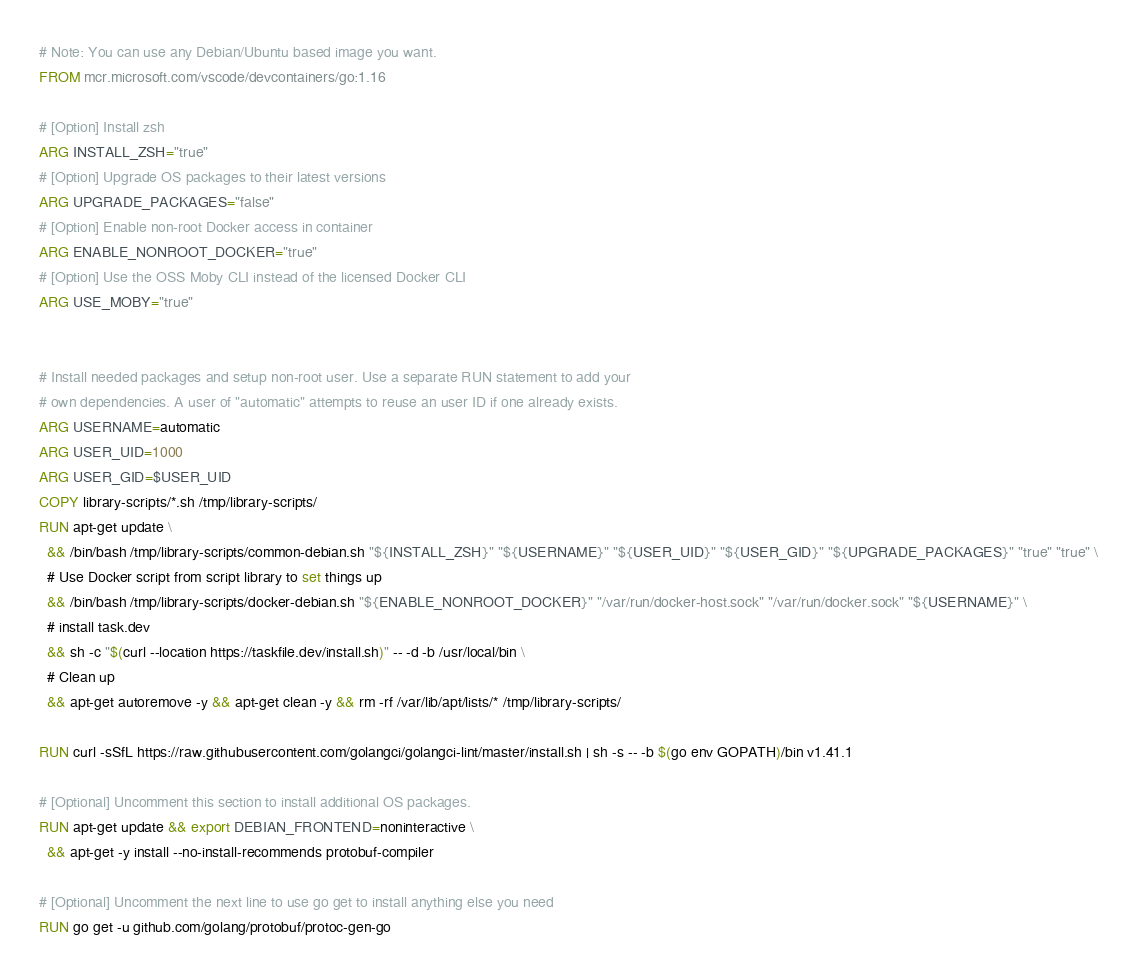Convert code to text. <code><loc_0><loc_0><loc_500><loc_500><_Dockerfile_># Note: You can use any Debian/Ubuntu based image you want. 
FROM mcr.microsoft.com/vscode/devcontainers/go:1.16

# [Option] Install zsh
ARG INSTALL_ZSH="true"
# [Option] Upgrade OS packages to their latest versions
ARG UPGRADE_PACKAGES="false"
# [Option] Enable non-root Docker access in container
ARG ENABLE_NONROOT_DOCKER="true"
# [Option] Use the OSS Moby CLI instead of the licensed Docker CLI
ARG USE_MOBY="true"


# Install needed packages and setup non-root user. Use a separate RUN statement to add your
# own dependencies. A user of "automatic" attempts to reuse an user ID if one already exists.
ARG USERNAME=automatic
ARG USER_UID=1000
ARG USER_GID=$USER_UID
COPY library-scripts/*.sh /tmp/library-scripts/
RUN apt-get update \
  && /bin/bash /tmp/library-scripts/common-debian.sh "${INSTALL_ZSH}" "${USERNAME}" "${USER_UID}" "${USER_GID}" "${UPGRADE_PACKAGES}" "true" "true" \
  # Use Docker script from script library to set things up
  && /bin/bash /tmp/library-scripts/docker-debian.sh "${ENABLE_NONROOT_DOCKER}" "/var/run/docker-host.sock" "/var/run/docker.sock" "${USERNAME}" \
  # install task.dev
  && sh -c "$(curl --location https://taskfile.dev/install.sh)" -- -d -b /usr/local/bin \
  # Clean up
  && apt-get autoremove -y && apt-get clean -y && rm -rf /var/lib/apt/lists/* /tmp/library-scripts/

RUN curl -sSfL https://raw.githubusercontent.com/golangci/golangci-lint/master/install.sh | sh -s -- -b $(go env GOPATH)/bin v1.41.1

# [Optional] Uncomment this section to install additional OS packages.
RUN apt-get update && export DEBIAN_FRONTEND=noninteractive \
  && apt-get -y install --no-install-recommends protobuf-compiler

# [Optional] Uncomment the next line to use go get to install anything else you need
RUN go get -u github.com/golang/protobuf/protoc-gen-go
</code> 